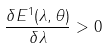Convert formula to latex. <formula><loc_0><loc_0><loc_500><loc_500>\frac { \delta E ^ { 1 } ( \lambda , \theta ) } { \delta \lambda } > 0</formula> 